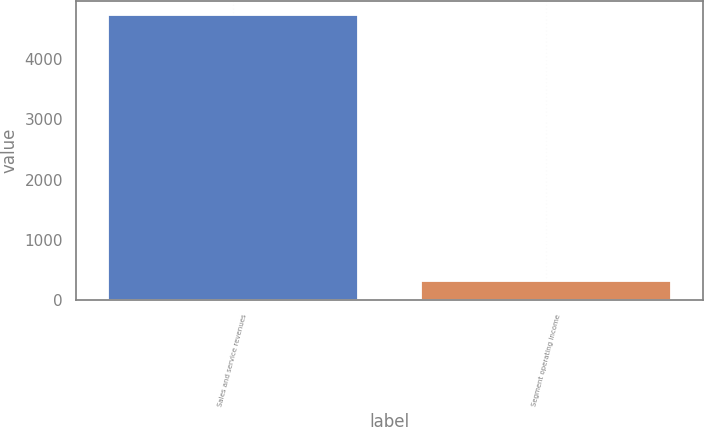<chart> <loc_0><loc_0><loc_500><loc_500><bar_chart><fcel>Sales and service revenues<fcel>Segment operating income<nl><fcel>4722<fcel>318<nl></chart> 